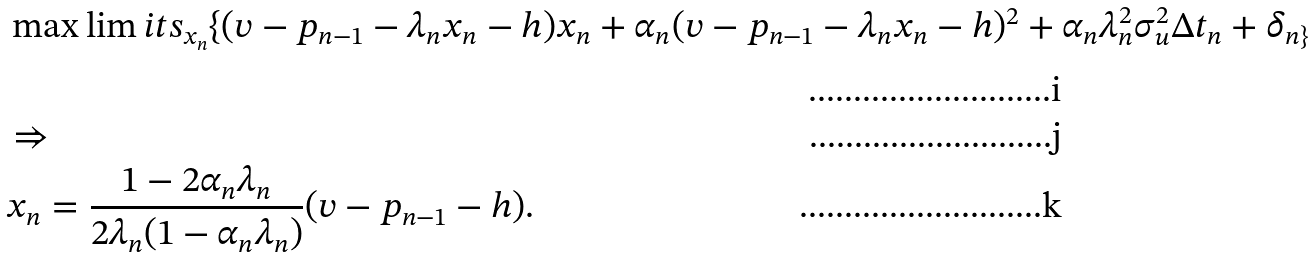Convert formula to latex. <formula><loc_0><loc_0><loc_500><loc_500>& \max \lim i t s _ { x _ { n } } \{ ( v - p _ { n - 1 } - \lambda _ { n } x _ { n } - h ) x _ { n } + \alpha _ { n } ( v - p _ { n - 1 } - \lambda _ { n } x _ { n } - h ) ^ { 2 } + \alpha _ { n } \lambda ^ { 2 } _ { n } \sigma ^ { 2 } _ { u } \Delta { t _ { n } } + \delta _ { n \} } \\ & \Rightarrow \\ & x _ { n } = \frac { 1 - 2 \alpha _ { n } \lambda _ { n } } { 2 \lambda _ { n } ( 1 - \alpha _ { n } \lambda _ { n } ) } ( v - p _ { n - 1 } - h ) .</formula> 